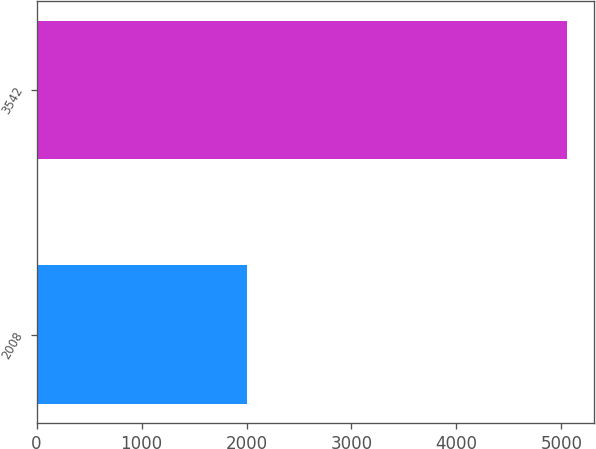Convert chart. <chart><loc_0><loc_0><loc_500><loc_500><bar_chart><fcel>2008<fcel>3542<nl><fcel>2007<fcel>5054<nl></chart> 